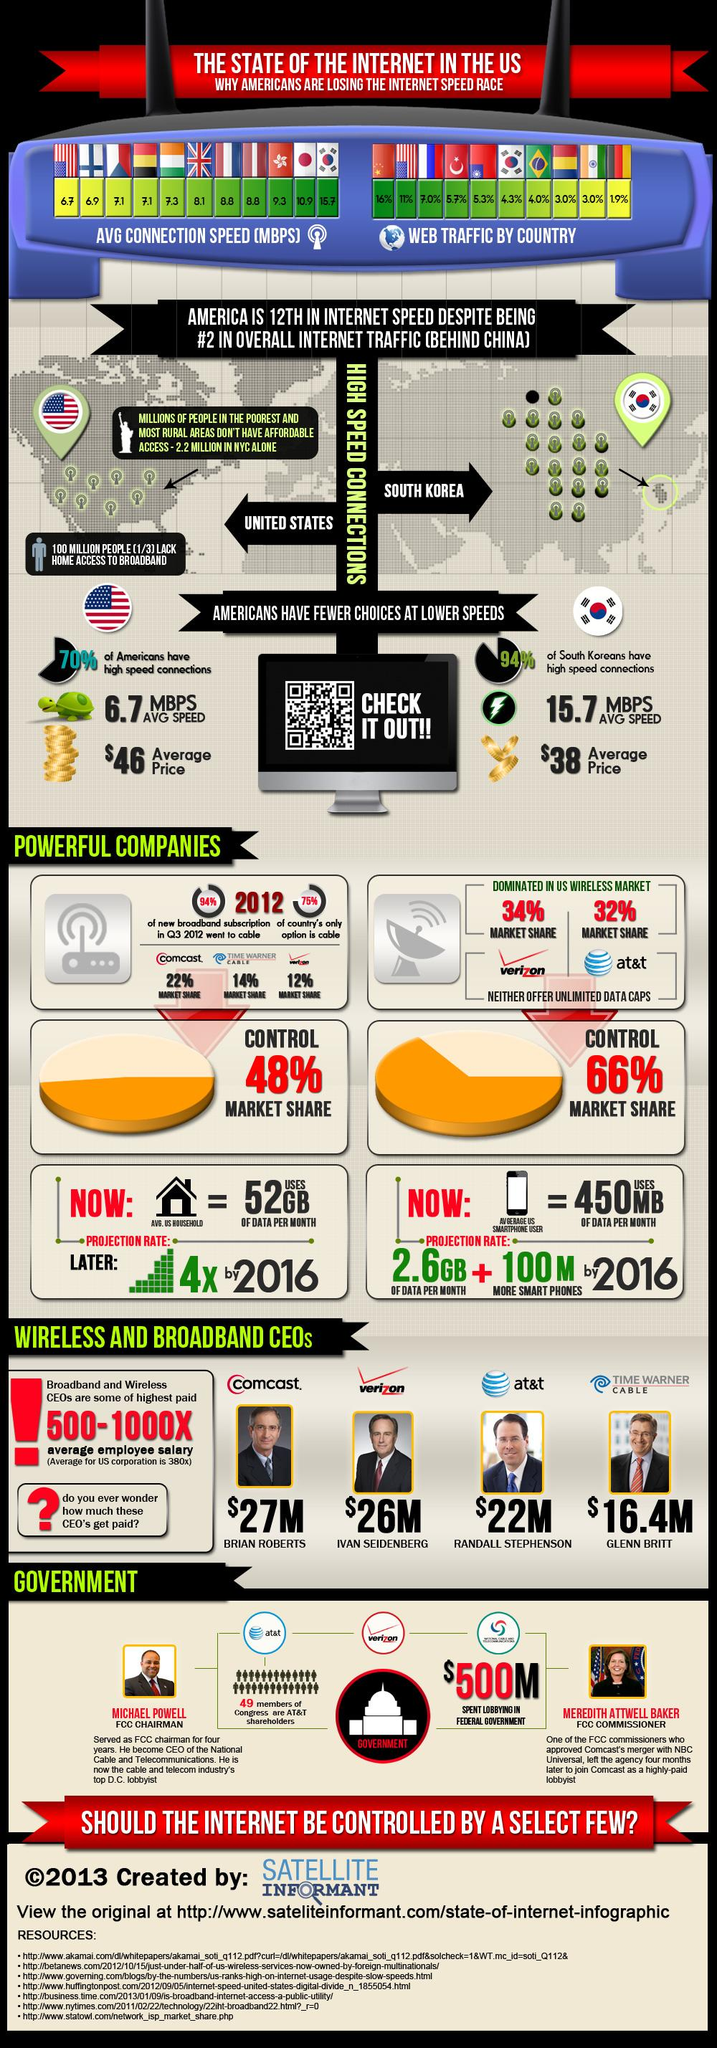Point out several critical features in this image. In 2013, the average internet connection speed in the UK was 8.1 megabits per second. According to recent data, cable is the most widely used type of broadband connection among the US population, with 75% of the population using this type of connection. In 2013, South Korea accounted for 4.3% of total web traffic. Verizon telecommunication company held a significant 34% market share in the US wireless industry in 2012. In 2013, Randall Stephenson served as the CEO of AT&T, a telecommunications company. 